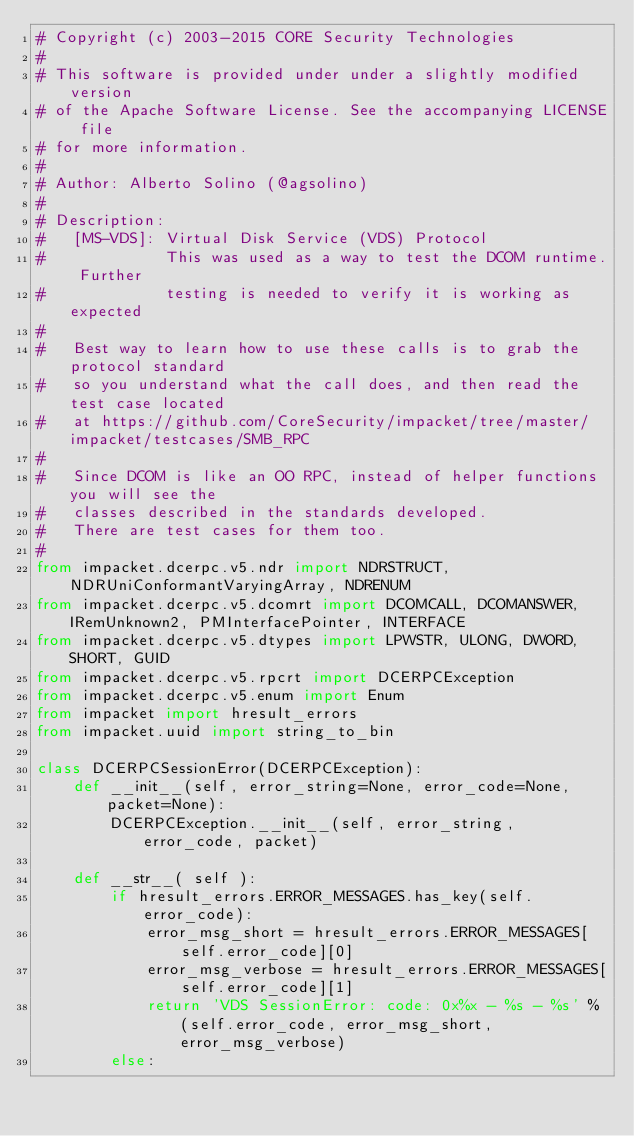<code> <loc_0><loc_0><loc_500><loc_500><_Python_># Copyright (c) 2003-2015 CORE Security Technologies
#
# This software is provided under under a slightly modified version
# of the Apache Software License. See the accompanying LICENSE file
# for more information.
#
# Author: Alberto Solino (@agsolino)
#
# Description:
#   [MS-VDS]: Virtual Disk Service (VDS) Protocol
#             This was used as a way to test the DCOM runtime. Further 
#             testing is needed to verify it is working as expected
#
#   Best way to learn how to use these calls is to grab the protocol standard
#   so you understand what the call does, and then read the test case located
#   at https://github.com/CoreSecurity/impacket/tree/master/impacket/testcases/SMB_RPC
#
#   Since DCOM is like an OO RPC, instead of helper functions you will see the 
#   classes described in the standards developed. 
#   There are test cases for them too. 
#
from impacket.dcerpc.v5.ndr import NDRSTRUCT, NDRUniConformantVaryingArray, NDRENUM
from impacket.dcerpc.v5.dcomrt import DCOMCALL, DCOMANSWER, IRemUnknown2, PMInterfacePointer, INTERFACE
from impacket.dcerpc.v5.dtypes import LPWSTR, ULONG, DWORD, SHORT, GUID
from impacket.dcerpc.v5.rpcrt import DCERPCException
from impacket.dcerpc.v5.enum import Enum
from impacket import hresult_errors
from impacket.uuid import string_to_bin

class DCERPCSessionError(DCERPCException):
    def __init__(self, error_string=None, error_code=None, packet=None):
        DCERPCException.__init__(self, error_string, error_code, packet)

    def __str__( self ):
        if hresult_errors.ERROR_MESSAGES.has_key(self.error_code):
            error_msg_short = hresult_errors.ERROR_MESSAGES[self.error_code][0]
            error_msg_verbose = hresult_errors.ERROR_MESSAGES[self.error_code][1] 
            return 'VDS SessionError: code: 0x%x - %s - %s' % (self.error_code, error_msg_short, error_msg_verbose)
        else:</code> 